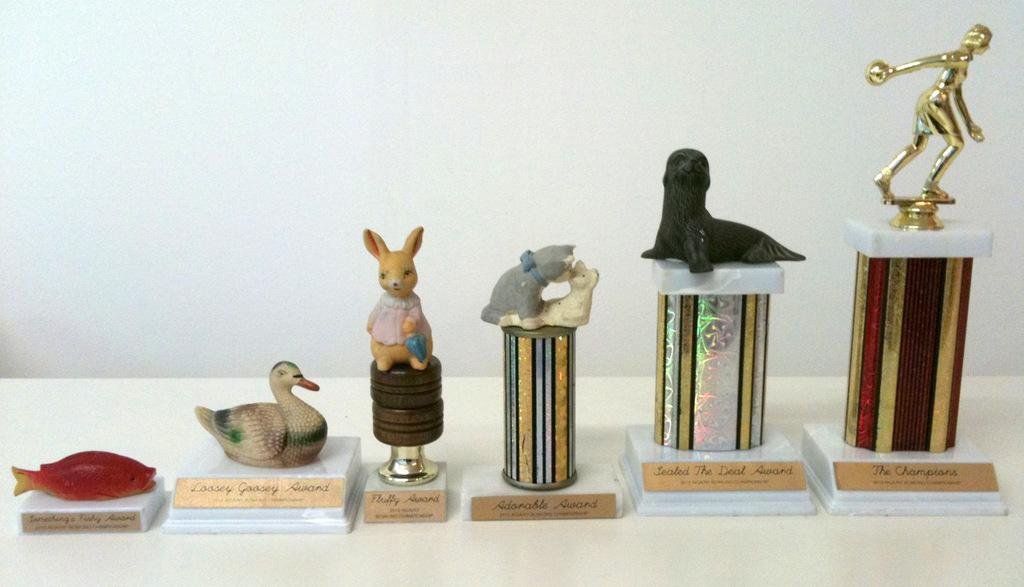What objects are on the platform in the image? There are toys on a platform in the image. What color is the background of the image? The background of the image is white. Can you hear the toys laughing in the image? There is no sound in the image, so it is not possible to hear the toys laughing. 